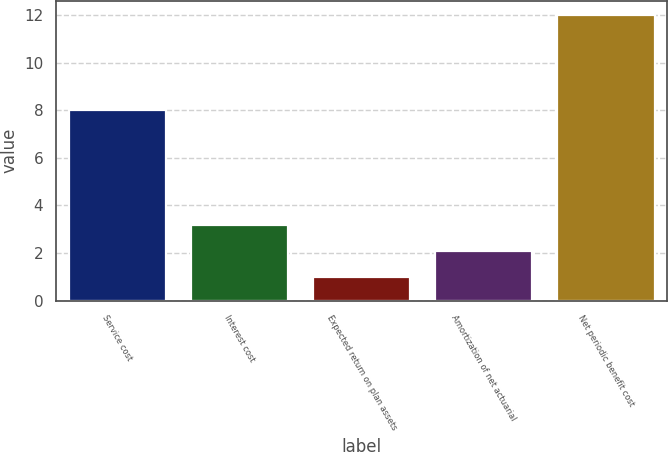<chart> <loc_0><loc_0><loc_500><loc_500><bar_chart><fcel>Service cost<fcel>Interest cost<fcel>Expected return on plan assets<fcel>Amortization of net actuarial<fcel>Net periodic benefit cost<nl><fcel>8<fcel>3.2<fcel>1<fcel>2.1<fcel>12<nl></chart> 